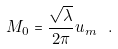<formula> <loc_0><loc_0><loc_500><loc_500>M _ { 0 } = \frac { \sqrt { \lambda } } { 2 \pi } u _ { m } \ .</formula> 